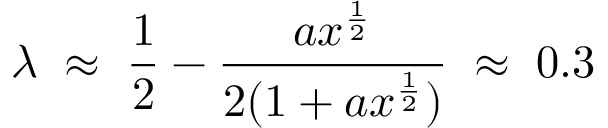<formula> <loc_0><loc_0><loc_500><loc_500>\lambda \, \approx \, \frac { 1 } { 2 } - \frac { a x ^ { \frac { 1 } { 2 } } } { 2 ( 1 + a x ^ { \frac { 1 } { 2 } } ) } \, \approx \, 0 . 3</formula> 